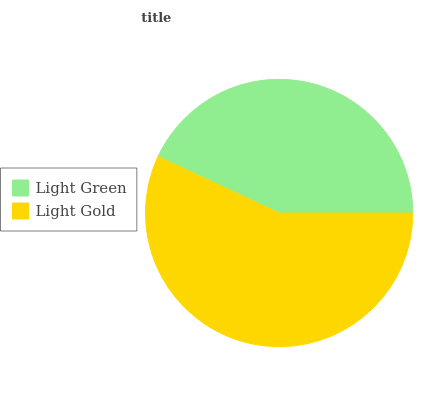Is Light Green the minimum?
Answer yes or no. Yes. Is Light Gold the maximum?
Answer yes or no. Yes. Is Light Gold the minimum?
Answer yes or no. No. Is Light Gold greater than Light Green?
Answer yes or no. Yes. Is Light Green less than Light Gold?
Answer yes or no. Yes. Is Light Green greater than Light Gold?
Answer yes or no. No. Is Light Gold less than Light Green?
Answer yes or no. No. Is Light Gold the high median?
Answer yes or no. Yes. Is Light Green the low median?
Answer yes or no. Yes. Is Light Green the high median?
Answer yes or no. No. Is Light Gold the low median?
Answer yes or no. No. 